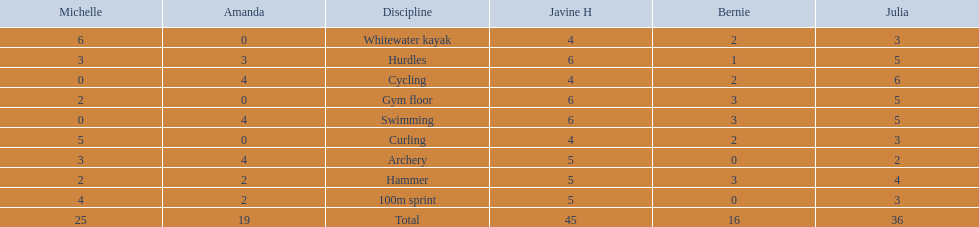Who earned the most total points? Javine H. 